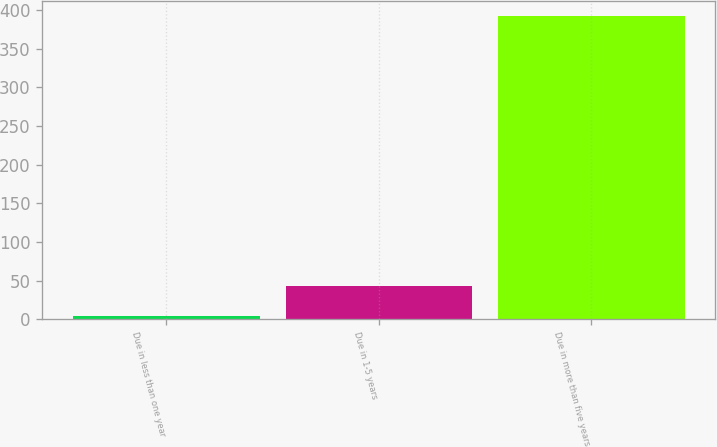Convert chart to OTSL. <chart><loc_0><loc_0><loc_500><loc_500><bar_chart><fcel>Due in less than one year<fcel>Due in 1-5 years<fcel>Due in more than five years<nl><fcel>5<fcel>43.7<fcel>392<nl></chart> 